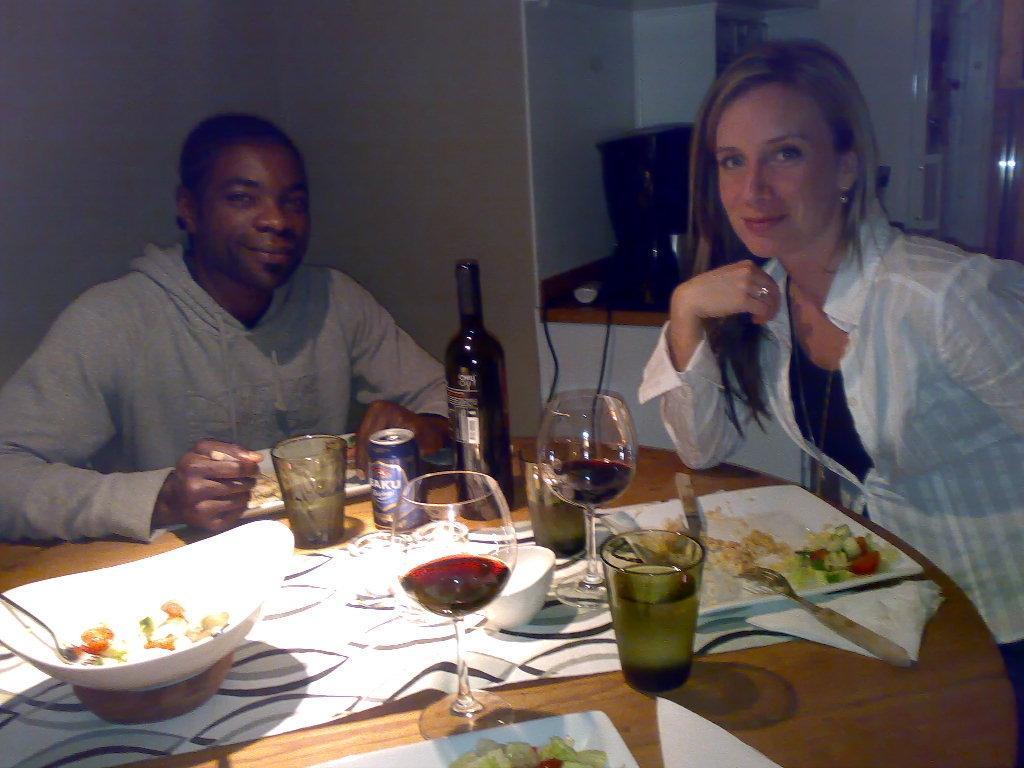In one or two sentences, can you explain what this image depicts? on a wooden table there are glasses, thin, glass bottle, bowl, food, plate, fork. 2 people are seated. the person at the right is wearing white shirt. the person at the left is wearing a grey t shirt and smiling. behind them there is a wall. 